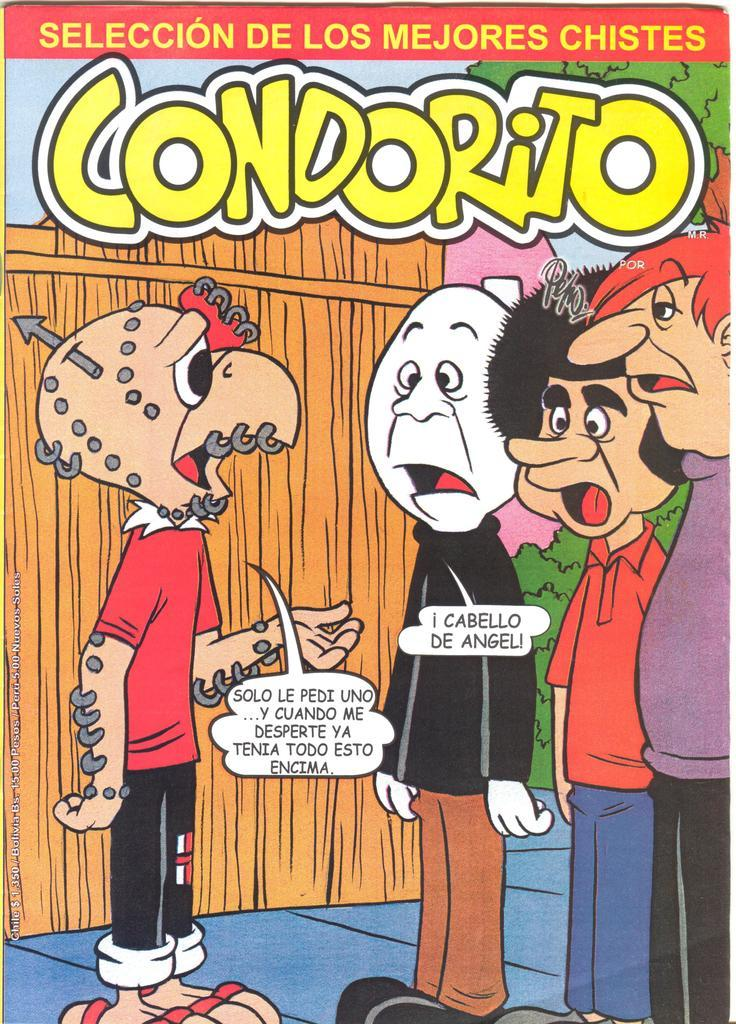What type of image is being described? The image is an animation cartoon. What is the main action taking place in the image? There is a person standing and speaking. What is the speaker wearing? The person is wearing a red color t-shirt. How many other persons are present in the image? There are three other persons standing on the right side. What are the other persons doing in the image? The three persons are listening to the speaker. Can you see any cobwebs in the image? There is no mention of cobwebs in the image, as it is an animation cartoon featuring people. Is there a stick being used by any of the characters in the image? There is no mention of a stick being used by any of the characters in the image. 